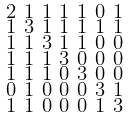Convert formula to latex. <formula><loc_0><loc_0><loc_500><loc_500>\begin{smallmatrix} 2 & 1 & 1 & 1 & 1 & 0 & 1 \\ 1 & 3 & 1 & 1 & 1 & 1 & 1 \\ 1 & 1 & 3 & 1 & 1 & 0 & 0 \\ 1 & 1 & 1 & 3 & 0 & 0 & 0 \\ 1 & 1 & 1 & 0 & 3 & 0 & 0 \\ 0 & 1 & 0 & 0 & 0 & 3 & 1 \\ 1 & 1 & 0 & 0 & 0 & 1 & 3 \end{smallmatrix}</formula> 